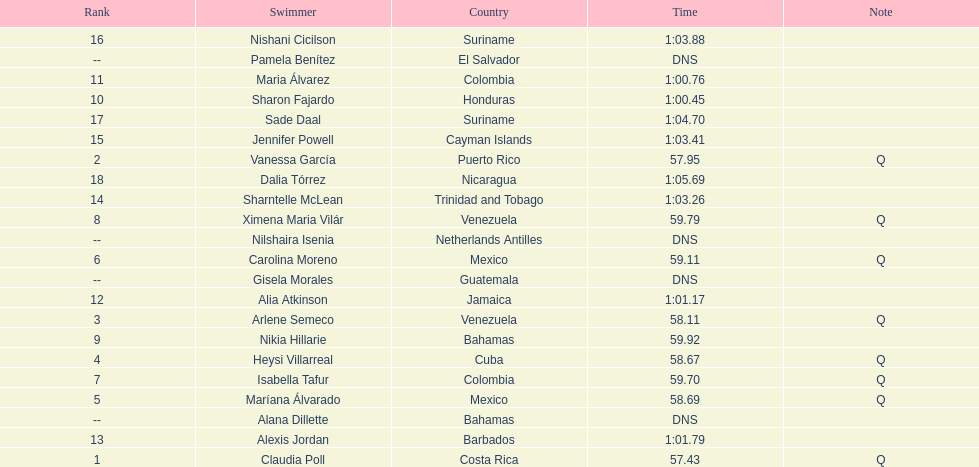Who was the only individual from cuba to secure a position in the top eight? Heysi Villarreal. 